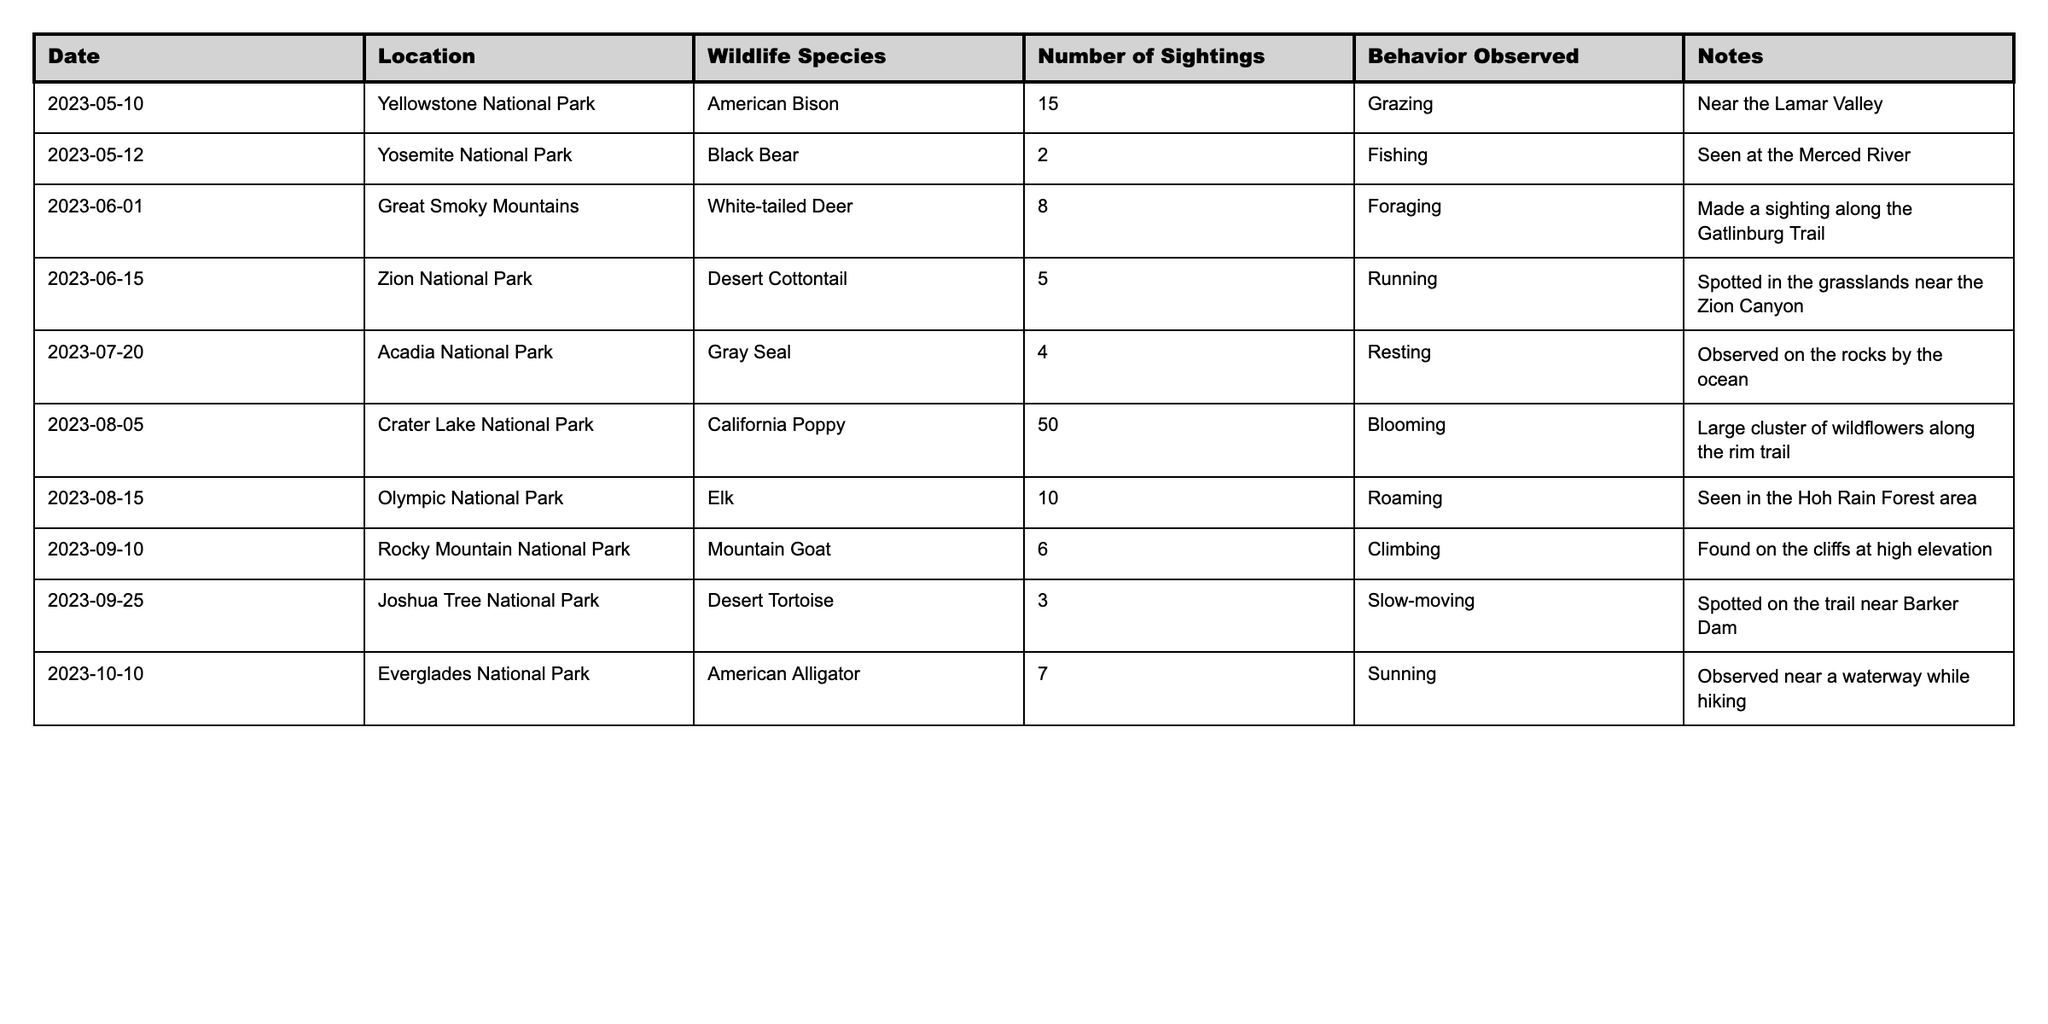What's the total number of wildlife sightings recorded in the log? To find the total number of wildlife sightings, we sum the values in the "Number of Sightings" column of the table: 15 + 2 + 8 + 5 + 4 + 50 + 10 + 6 + 3 + 7 = 110.
Answer: 110 Which wildlife species was sighted the most, and how many times? We look for the maximum value in the "Number of Sightings" column. The maximum is 50 for the California Poppy.
Answer: California Poppy, 50 How many different locations were visited for wildlife sightings? The distinct entries in the "Location" column are counted: Yellowstone, Yosemite, Great Smoky Mountains, Zion, Acadia, Crater Lake, Olympic, Rocky Mountain, Joshua Tree, and Everglades total to 10 locations.
Answer: 10 Did the family see the Black Bear in any location other than Yosemite National Park? Check the entries for Black Bear sightings in the table: there is only one record, and it is located at Yosemite National Park.
Answer: No What is the average number of sightings per location? We total the sightings (110) and divide by the number of distinct locations (10) to get the average: 110 / 10 = 11.
Answer: 11 In which national park was the Desert Tortoise seen, and what was its behavior? Look for the row corresponding to Desert Tortoise in the table: it was seen in Joshua Tree National Park and was noted as slow-moving.
Answer: Joshua Tree National Park, slow-moving How many species observed displayed the behavior of grazing? We filter the "Behavior Observed" column for entries that mention grazing: only the American Bison exhibits this behavior, noted once.
Answer: 1 What is the total number of sightings for animals recorded in October? Identify the entries for October: the American Alligator was sighted 7 times on October 10.
Answer: 7 How many species have been noted for their behavior of running? Check the "Behavior Observed" for "Running": only the Desert Cottontail fits this description from the sightings log.
Answer: 1 Which location had the least number of wildlife sightings, and what species was observed there? We look for the minimum value in the "Number of Sightings": Joshua Tree National Park had 3 sightings of the Desert Tortoise.
Answer: Joshua Tree National Park, Desert Tortoise, 3 